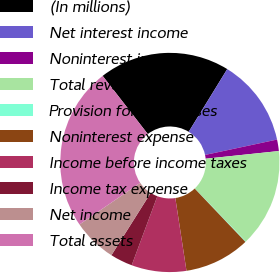<chart> <loc_0><loc_0><loc_500><loc_500><pie_chart><fcel>(In millions)<fcel>Net interest income<fcel>Noninterest income<fcel>Total revenue<fcel>Provision for loan losses<fcel>Noninterest expense<fcel>Income before income taxes<fcel>Income tax expense<fcel>Net income<fcel>Total assets<nl><fcel>19.27%<fcel>12.88%<fcel>1.69%<fcel>14.47%<fcel>0.09%<fcel>9.68%<fcel>8.08%<fcel>3.29%<fcel>6.48%<fcel>24.06%<nl></chart> 